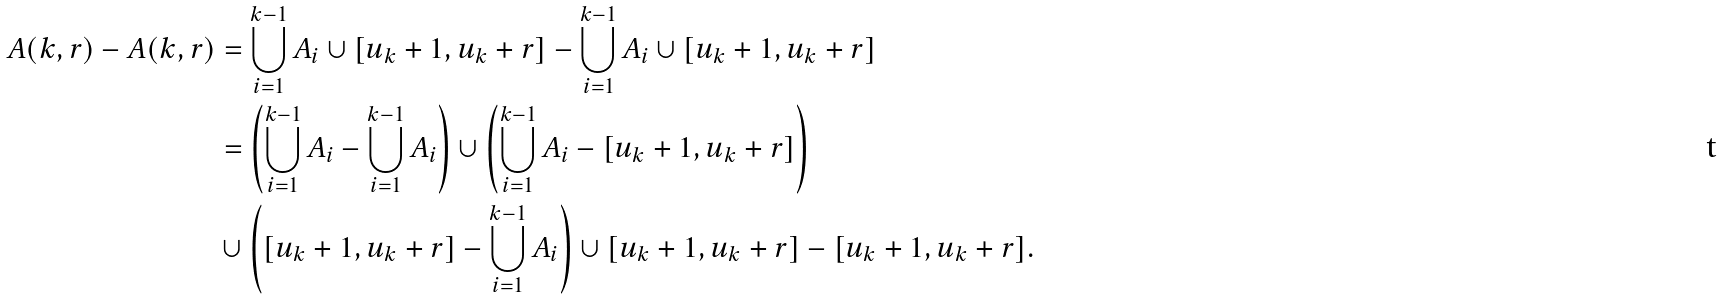Convert formula to latex. <formula><loc_0><loc_0><loc_500><loc_500>A ( k , r ) - A ( k , r ) & = \bigcup _ { i = 1 } ^ { k - 1 } A _ { i } \cup [ u _ { k } + 1 , u _ { k } + r ] - \bigcup _ { i = 1 } ^ { k - 1 } A _ { i } \cup [ u _ { k } + 1 , u _ { k } + r ] \\ & = \left ( \bigcup _ { i = 1 } ^ { k - 1 } A _ { i } - \bigcup _ { i = 1 } ^ { k - 1 } A _ { i } \right ) \cup \left ( \bigcup _ { i = 1 } ^ { k - 1 } A _ { i } - [ u _ { k } + 1 , u _ { k } + r ] \right ) \\ & \cup \left ( [ u _ { k } + 1 , u _ { k } + r ] - \bigcup _ { i = 1 } ^ { k - 1 } A _ { i } \right ) \cup [ u _ { k } + 1 , u _ { k } + r ] - [ u _ { k } + 1 , u _ { k } + r ] .</formula> 